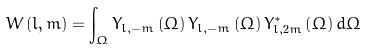<formula> <loc_0><loc_0><loc_500><loc_500>W \left ( l , m \right ) = \int _ { \Omega } Y _ { l , - m } \left ( \Omega \right ) Y _ { l , - m } \left ( \Omega \right ) Y ^ { * } _ { l , 2 m } \left ( \Omega \right ) d \Omega</formula> 